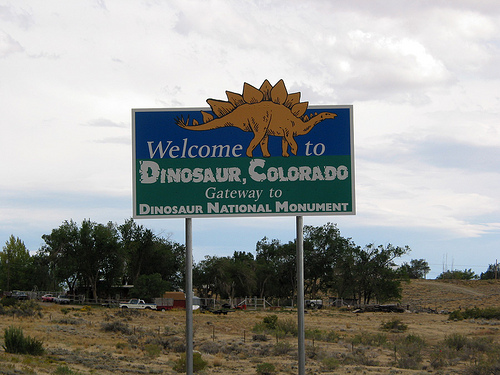<image>
Is the dinosaur above the ground? Yes. The dinosaur is positioned above the ground in the vertical space, higher up in the scene. Is there a dinosaur behind the sign? No. The dinosaur is not behind the sign. From this viewpoint, the dinosaur appears to be positioned elsewhere in the scene. 